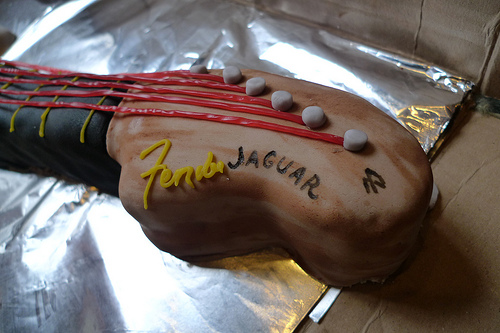<image>
Is there a tin foil behind the cake? No. The tin foil is not behind the cake. From this viewpoint, the tin foil appears to be positioned elsewhere in the scene. 